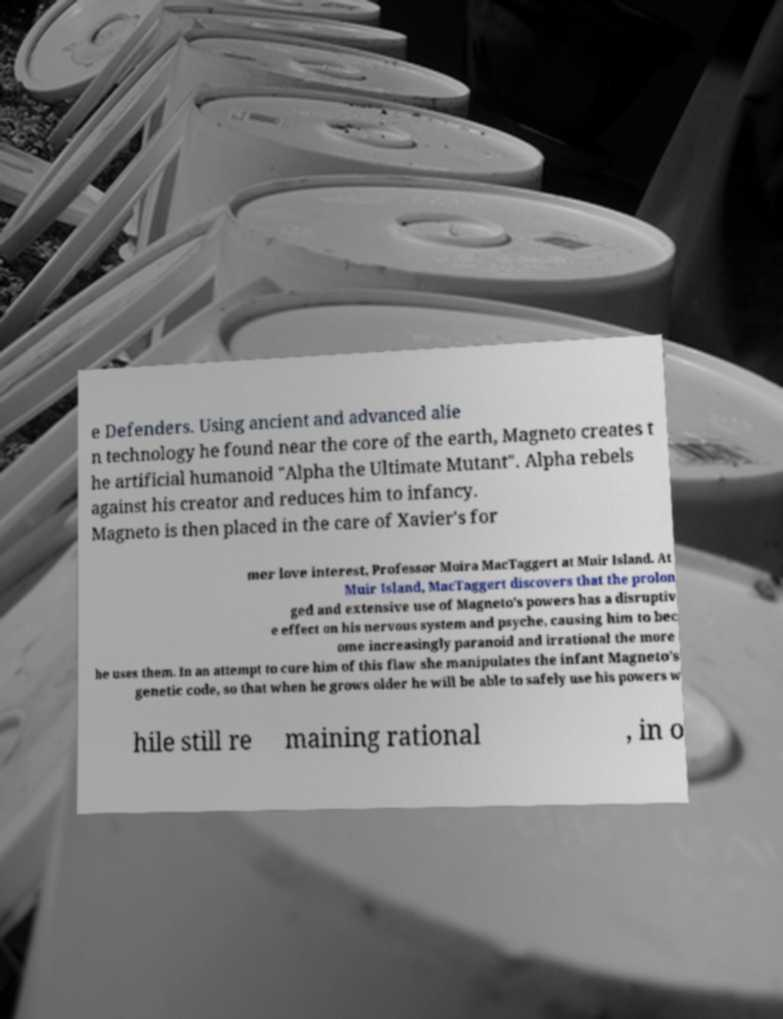Please identify and transcribe the text found in this image. e Defenders. Using ancient and advanced alie n technology he found near the core of the earth, Magneto creates t he artificial humanoid "Alpha the Ultimate Mutant". Alpha rebels against his creator and reduces him to infancy. Magneto is then placed in the care of Xavier's for mer love interest, Professor Moira MacTaggert at Muir Island. At Muir Island, MacTaggert discovers that the prolon ged and extensive use of Magneto's powers has a disruptiv e effect on his nervous system and psyche, causing him to bec ome increasingly paranoid and irrational the more he uses them. In an attempt to cure him of this flaw she manipulates the infant Magneto's genetic code, so that when he grows older he will be able to safely use his powers w hile still re maining rational , in o 